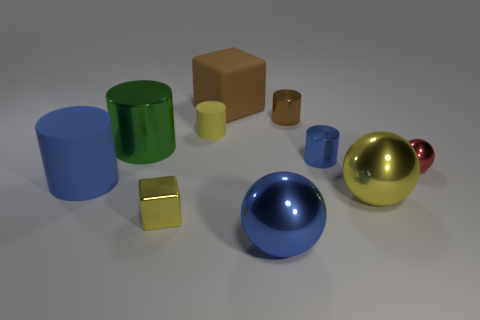Subtract all yellow metal balls. How many balls are left? 2 Subtract all yellow cylinders. How many cylinders are left? 4 Subtract all green balls. How many blue cylinders are left? 2 Subtract 3 cylinders. How many cylinders are left? 2 Subtract all balls. How many objects are left? 7 Subtract all yellow blocks. Subtract all red cylinders. How many blocks are left? 1 Subtract all cylinders. Subtract all tiny purple shiny spheres. How many objects are left? 5 Add 2 large green metal things. How many large green metal things are left? 3 Add 9 large red matte cylinders. How many large red matte cylinders exist? 9 Subtract 0 purple cylinders. How many objects are left? 10 